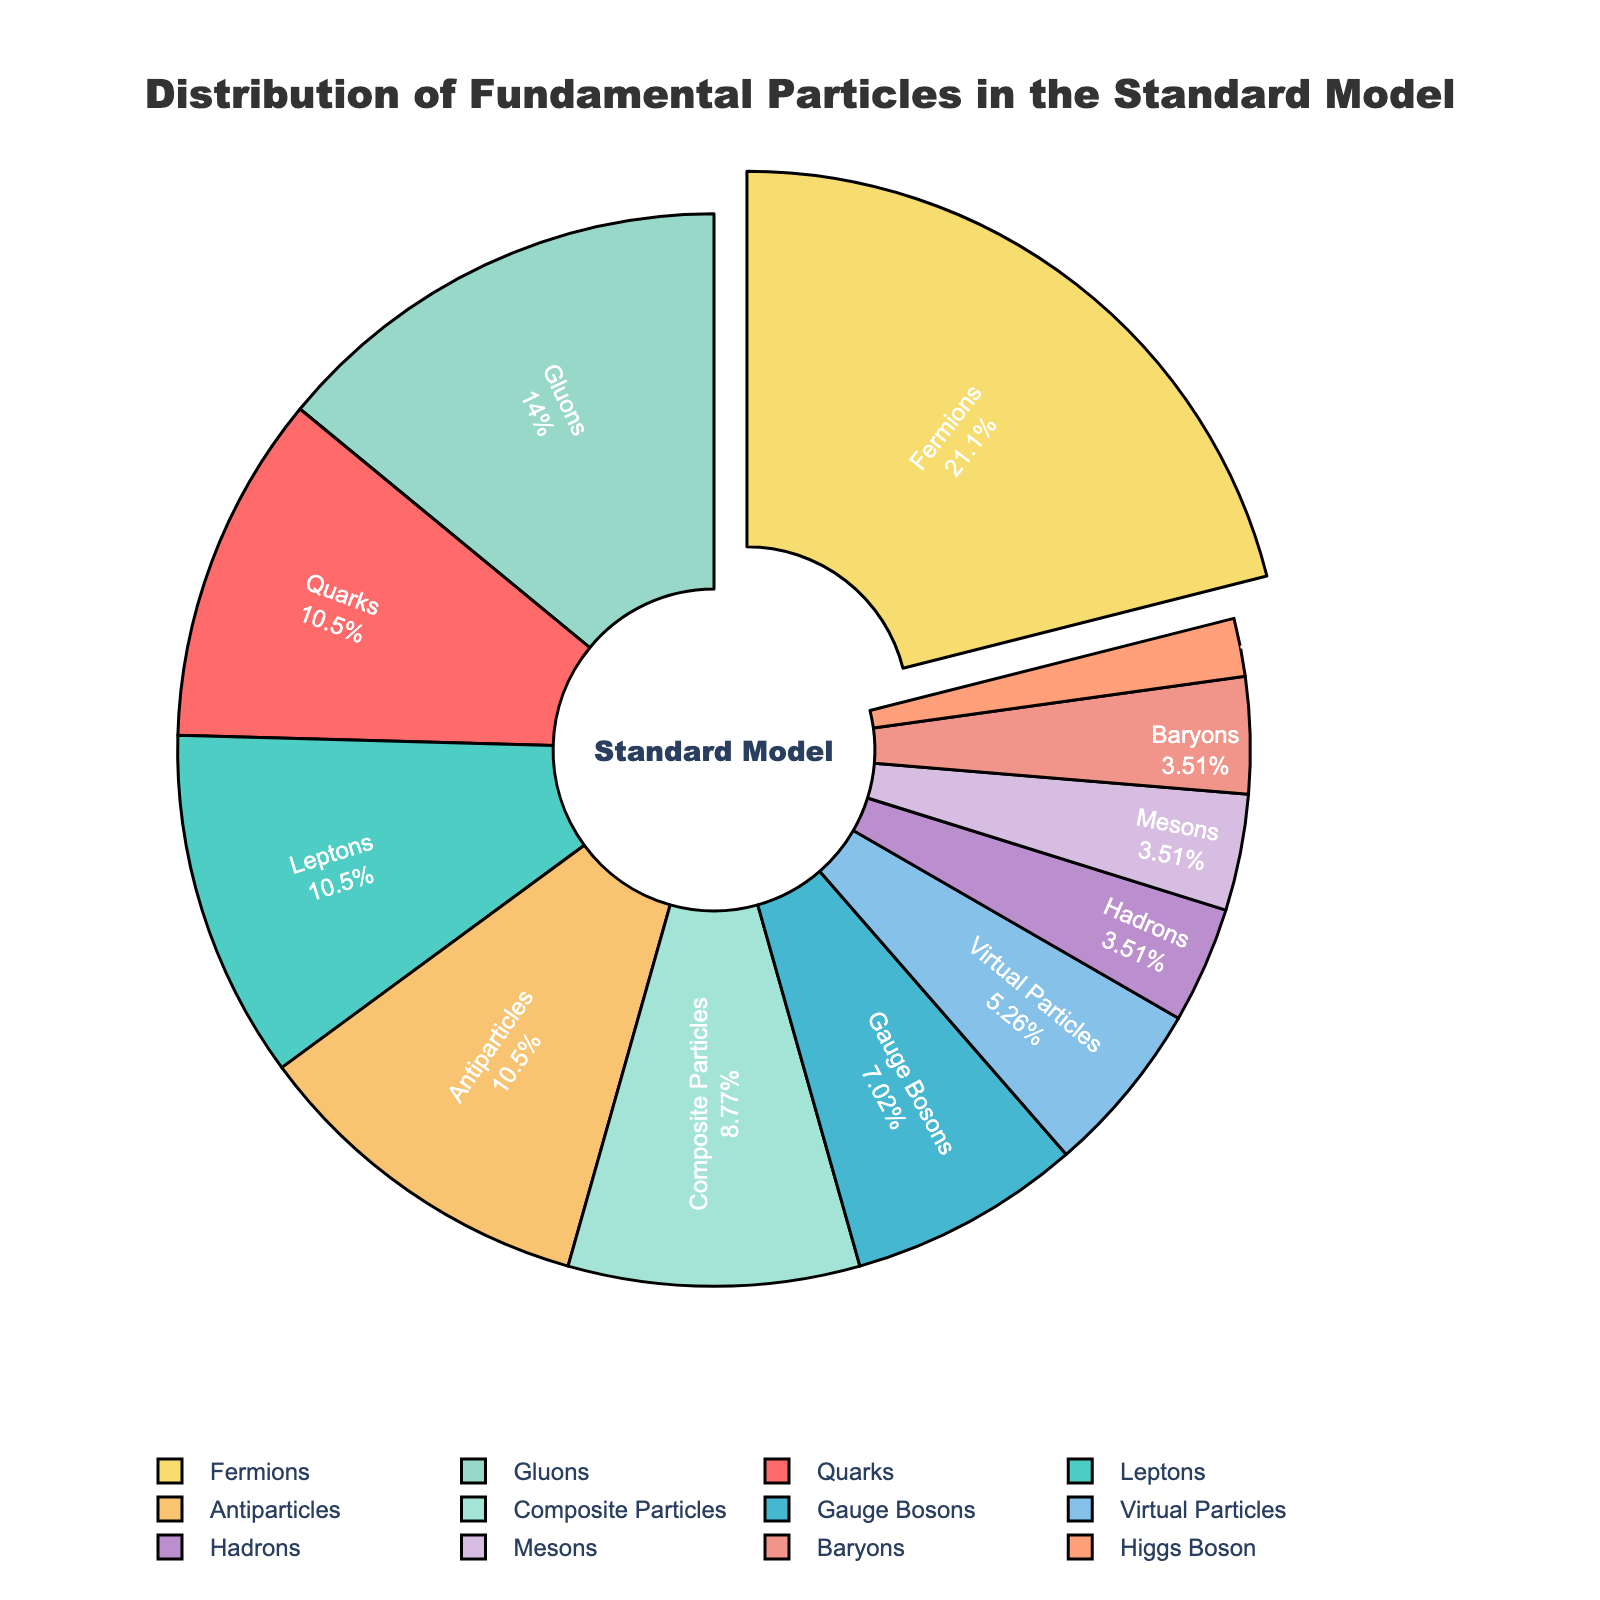Which category has the highest count? In the pie chart, the category with the highest count is typically distinguished by being pulled out slightly from the rest or having the largest segment. The chart shows Fermions as the largest with a segment pulled out, indicating it has the highest count.
Answer: Fermions What percentage of the particles are Quarks? To determine the percentage of Quarks, look at the pie chart segment labeled "Quarks" and read the percentage value. The segment shows that Quarks make up a specific portion of the whole.
Answer: 12.5% Are there more Gauge Bosons or Mesons? Compare the segments labeled "Gauge Bosons" and "Mesons" and check their counts. Gauge Bosons have a count of 4, while Mesons have a count of 2.
Answer: Gauge Bosons What is the combined percentage of Hadrons and Composite Particles? Add the counts of Hadrons (2) and Composite Particles (5), then calculate the combined percentage by dividing by the total count and multiplying by 100. (2 + 5) / 54 ≈ 0.1296, which is approximately 13%.
Answer: 13% Which category has the smallest count, and what is it? Check for the smallest segment in the pie chart, labeled "Higgs Boson," which indicates the Higgs Boson has the smallest count.
Answer: Higgs Boson, 1 Is the count of Antiparticles equal to the count of Leptons? Compare the segments labeled "Antiparticles" and "Leptons." Both segments have the same count of 6.
Answer: Yes How many categories have a count of exactly 2? Identify and count the segments with a count of 2 in the pie chart. "Hadrons," "Mesons," and "Baryons" each have a count of 2.
Answer: 3 What is the total count of all particles represented in the pie chart? Sum all individual counts from the pie chart: 6 (Quarks) + 6 (Leptons) + 4 (Gauge Bosons) + 1 (Higgs Boson) + 8 (Gluons) + 12 (Fermions) + 2 (Hadrons) + 2 (Mesons) + 2 (Baryons) + 5 (Composite Particles) + 3 (Virtual Particles) + 6 (Antiparticles) = 57.
Answer: 57 How does the count of Virtual Particles compare to that of Gluons? Compare the segments labeled "Virtual Particles" and "Gluons." The count of Virtual Particles is 3, and the count of Gluons is 8.
Answer: Less How does the combined count of Quarks, Leptons, and Gauge Bosons compare to the combined count of Gluons and Fermions? Add together the counts of Quarks (6), Leptons (6), and Gauge Bosons (4), which equals 16. Add together the counts of Gluons (8) and Fermions (12), which equals 20. Compare 16 to 20.
Answer: Less 